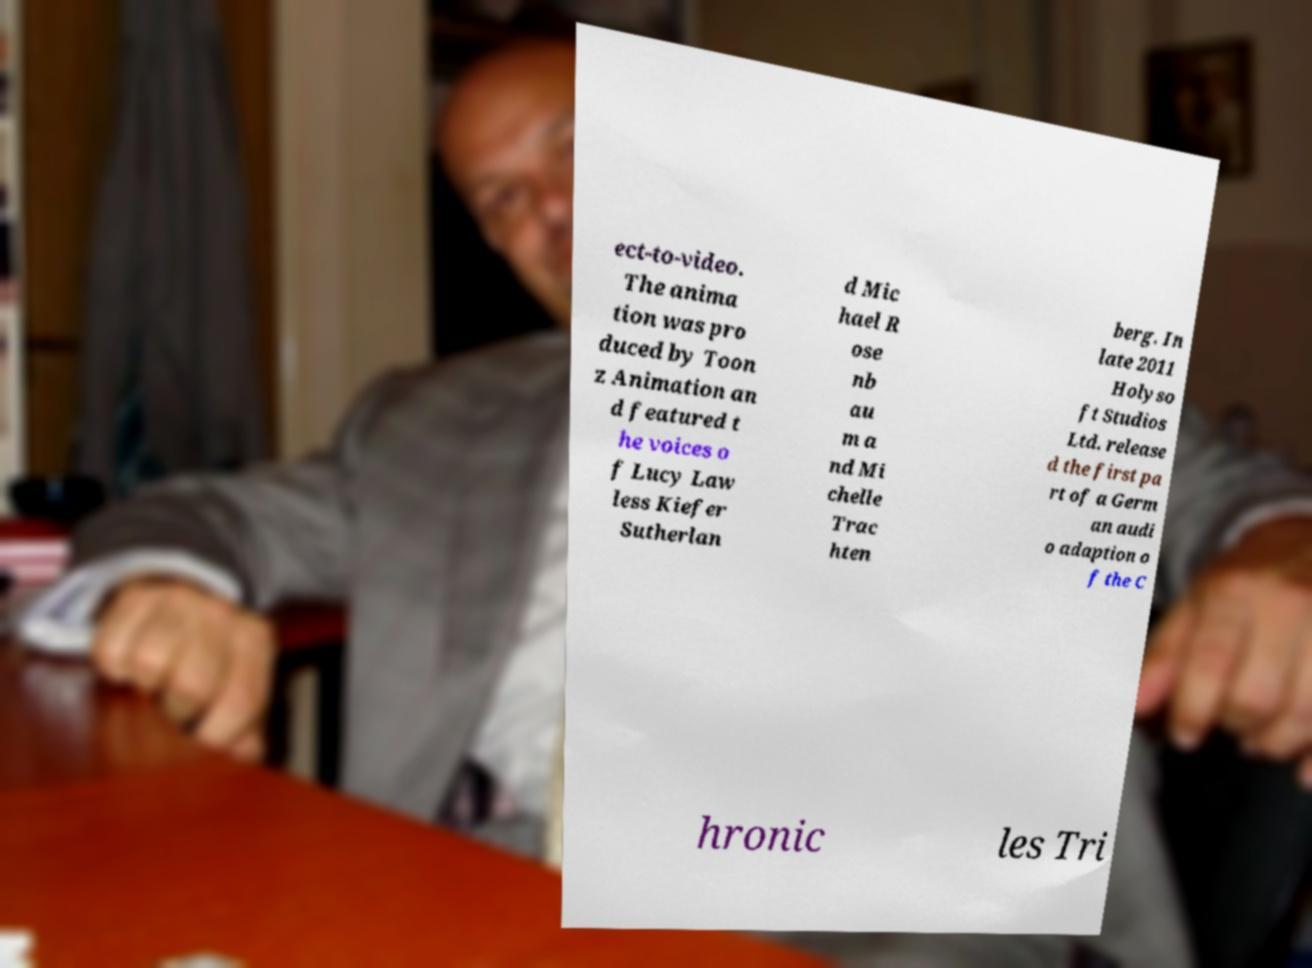Please read and relay the text visible in this image. What does it say? ect-to-video. The anima tion was pro duced by Toon z Animation an d featured t he voices o f Lucy Law less Kiefer Sutherlan d Mic hael R ose nb au m a nd Mi chelle Trac hten berg. In late 2011 Holyso ft Studios Ltd. release d the first pa rt of a Germ an audi o adaption o f the C hronic les Tri 